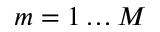Convert formula to latex. <formula><loc_0><loc_0><loc_500><loc_500>m = 1 \dots M</formula> 